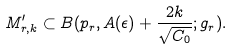<formula> <loc_0><loc_0><loc_500><loc_500>M _ { r , k } ^ { \prime } \subset B ( p _ { r } , A ( \epsilon ) + \frac { 2 k } { \sqrt { C _ { 0 } } } ; g _ { r } ) .</formula> 